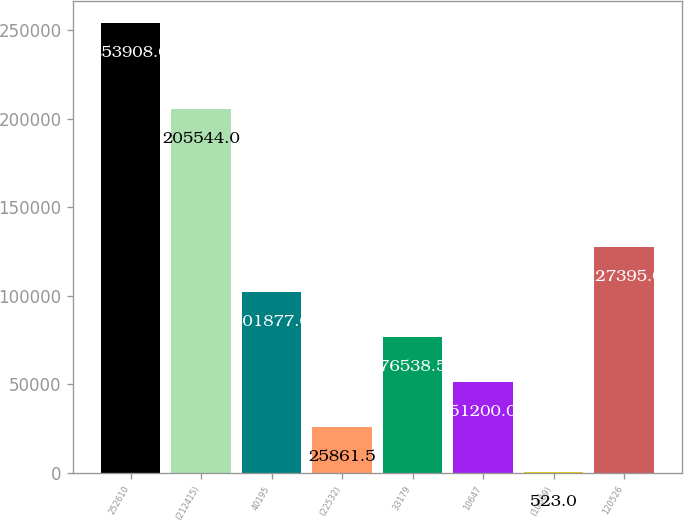<chart> <loc_0><loc_0><loc_500><loc_500><bar_chart><fcel>252610<fcel>(212415)<fcel>40195<fcel>(22532)<fcel>33179<fcel>10647<fcel>(10609)<fcel>120526<nl><fcel>253908<fcel>205544<fcel>101877<fcel>25861.5<fcel>76538.5<fcel>51200<fcel>523<fcel>127395<nl></chart> 